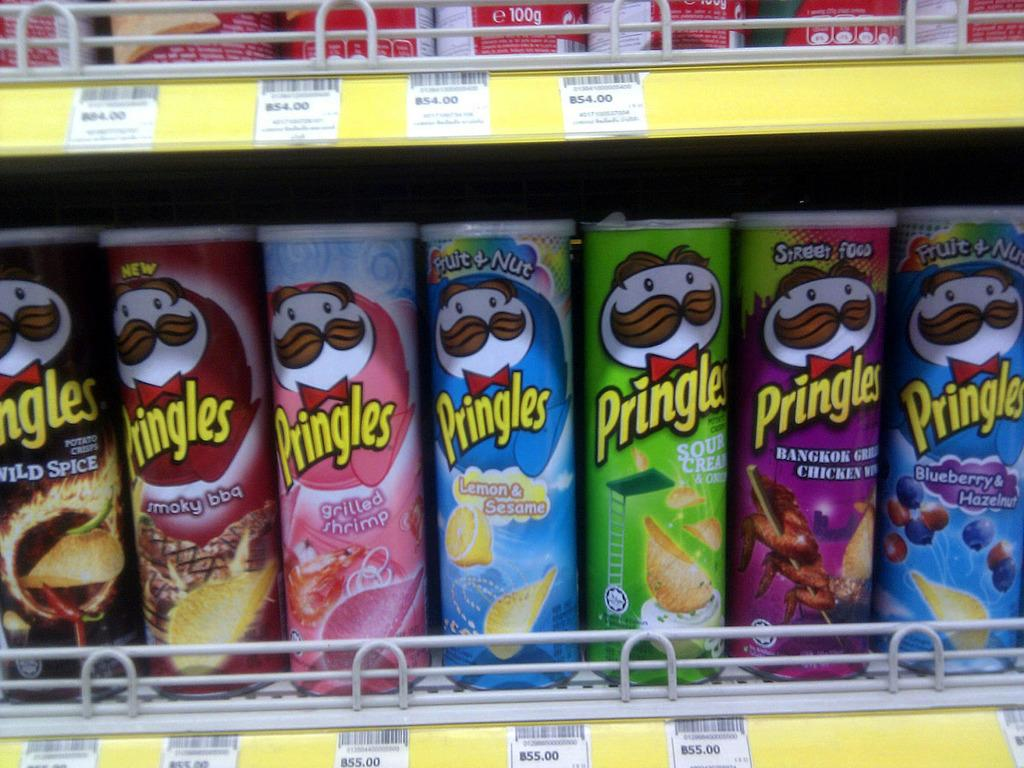<image>
Give a short and clear explanation of the subsequent image. Seven boxes of various flavoured Pringle crisps stands side by side on a shop shelf. 